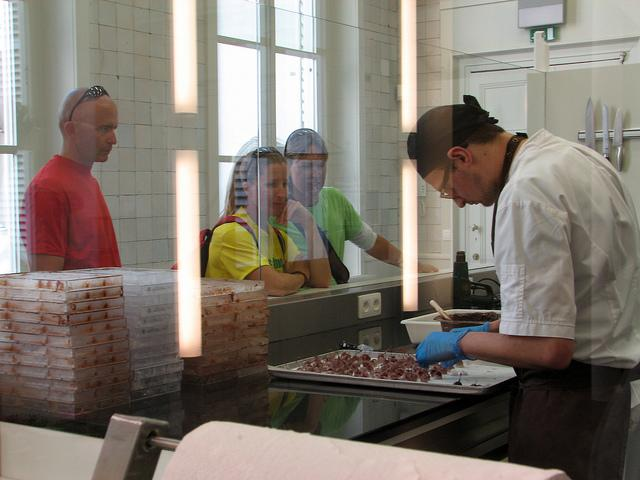What is the man using to cook? baking sheet 